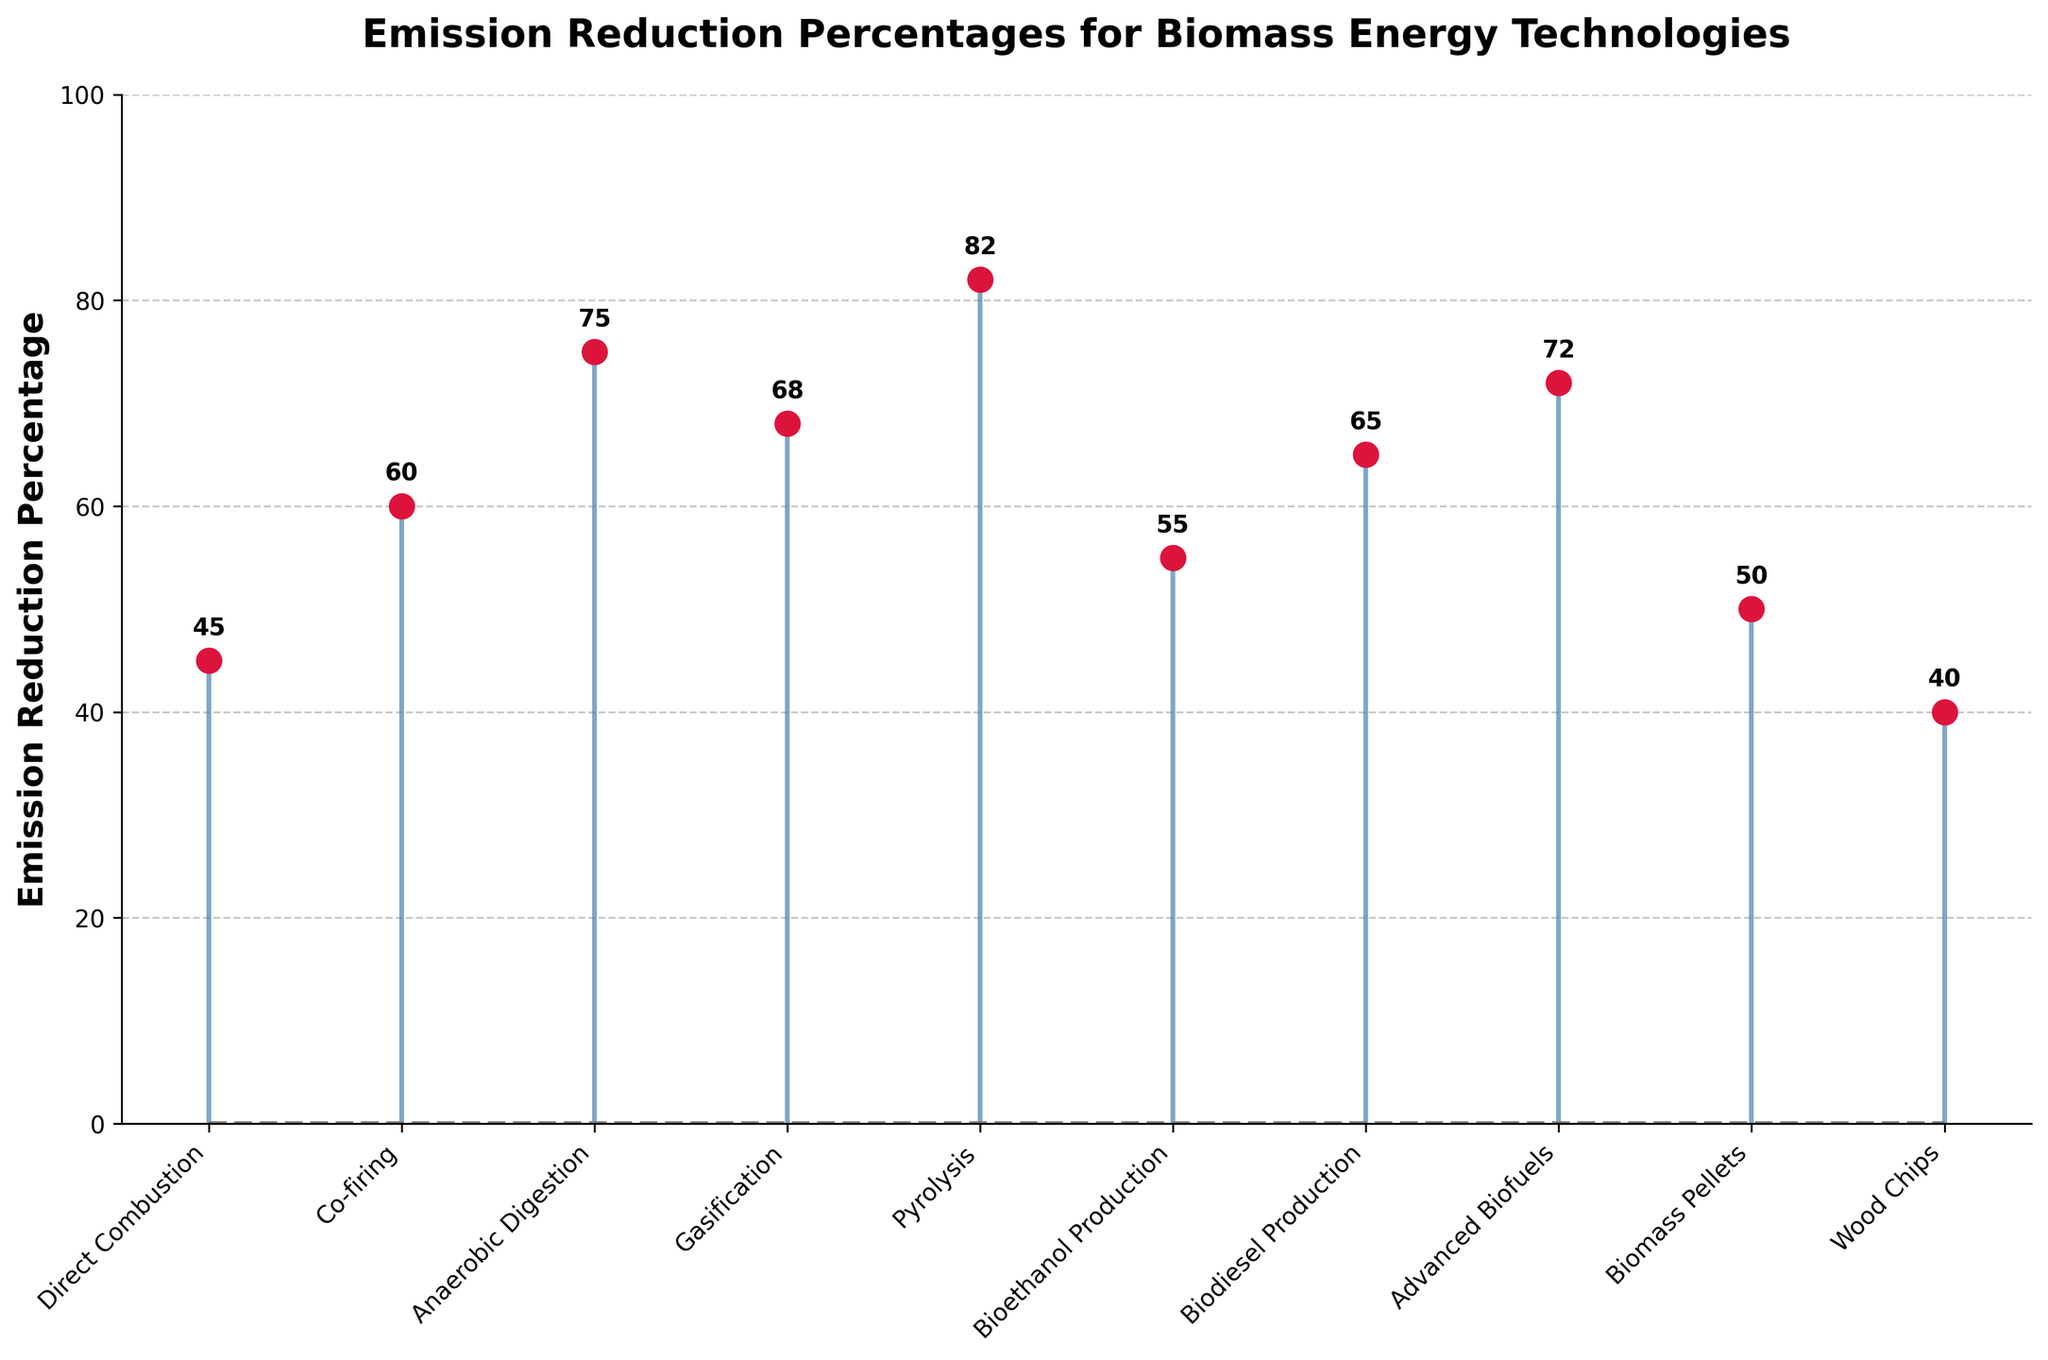What is the title of the plot? The title is displayed at the top of the plot and is "Emission Reduction Percentages for Biomass Energy Technologies".
Answer: Emission Reduction Percentages for Biomass Energy Technologies What is the highest emission reduction percentage and which technology does it belong to? By looking at the topmost stem marker, we see 82% for Pyrolysis.
Answer: 82%, Pyrolysis What is the lowest emission reduction percentage and which technology does it belong to? The bottommost stem marker indicates 40% for Wood Chips.
Answer: 40%, Wood Chips How many technologies have emission reductions higher than 60%? By counting the stems above the 60% line, we find Anaerobic Digestion, Gasification, Pyrolysis, Advanced Biofuels, and Biodiesel Production, totaling 5.
Answer: 5 What is the median emission reduction percentage for all technologies? After ordering the percentages (40, 45, 50, 55, 60, 65, 68, 72, 75, 82), the middle values are 60 and 65. The median is the average of these two values: (60 + 65) / 2 = 62.5.
Answer: 62.5 Which technology has an emission reduction percentage closest to 50%? The stem close to 50% is for Biomass Pellets with exactly 50%.
Answer: Biomass Pellets Compare the emission reduction percentages of Gasification and Bioethanol Production. Which is higher and by how much? Gasification has 68% and Bioethanol Production has 55%. The difference is 68 - 55 = 13%.
Answer: Gasification by 13% How does the emission reduction of Advanced Biofuels compare to that of Biodiesel Production? Advanced Biofuels have 72% while Biodiesel Production has 65%, with Advanced Biofuels being higher by 72 - 65 = 7%.
Answer: Advanced Biofuels by 7% What's the average emission reduction percentage of Direct Combustion and Co-firing? Sum of the percentages: 45 + 60 = 105. Average = 105 / 2 = 52.5.
Answer: 52.5 Is there any technology with an emission reduction percentage exactly at 75%? The marker for Anaerobic Digestion is exactly at the 75% mark.
Answer: Yes, Anaerobic Digestion 